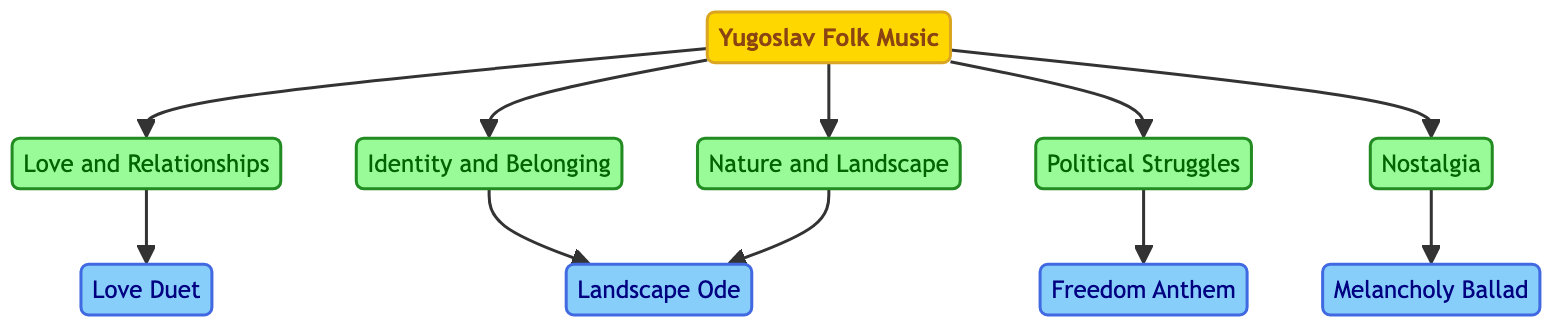What are the main themes derived from the origin? The origin node is "Yugoslav Folk Music," and from it, there are five edges leading to five themes: "Love and Relationships," "Identity and Belonging," "Political Struggles," "Nature and Landscape," and "Nostalgia."
Answer: Love and Relationships, Identity and Belonging, Political Struggles, Nature and Landscape, Nostalgia Which song is connected to the theme of Nostalgia? The "Nostalgia" theme has a directed edge leading to "Melancholy Ballad," indicating that this song reflects the theme of Nostalgia.
Answer: Melancholy Ballad How many songs are connected to the theme of Nature and Landscape? The "Nature and Landscape" theme connects to two songs: "Landscape Ode" and also has another directed edge leading to the same song again, counting only unique connections gives one unique song related to this theme.
Answer: 1 Identify the song that represents Political Struggles. There is a directed edge from the "Political Struggles" theme to the song labeled "Freedom Anthem," making this song representative of the theme.
Answer: Freedom Anthem What is the total number of edges in the diagram? Counting the connections between nodes (the directed edges), there are ten edges in total, connecting themes to songs and the origin to themes.
Answer: 10 Which theme has the most connections to songs? The theme "Love and Relationships" connects to one song: "Love Duet," while the "Nature and Landscape" also connects to "Landscape Ode." No other themes connect to more than one unique song, revealing a tie here.
Answer: Love and Relationships, Nature and Landscape 